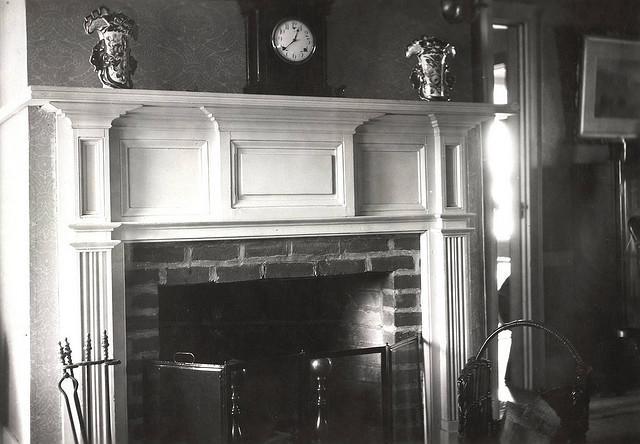How many items are on the mantle?
Give a very brief answer. 3. How many people are hitting a tennis ball?
Give a very brief answer. 0. 